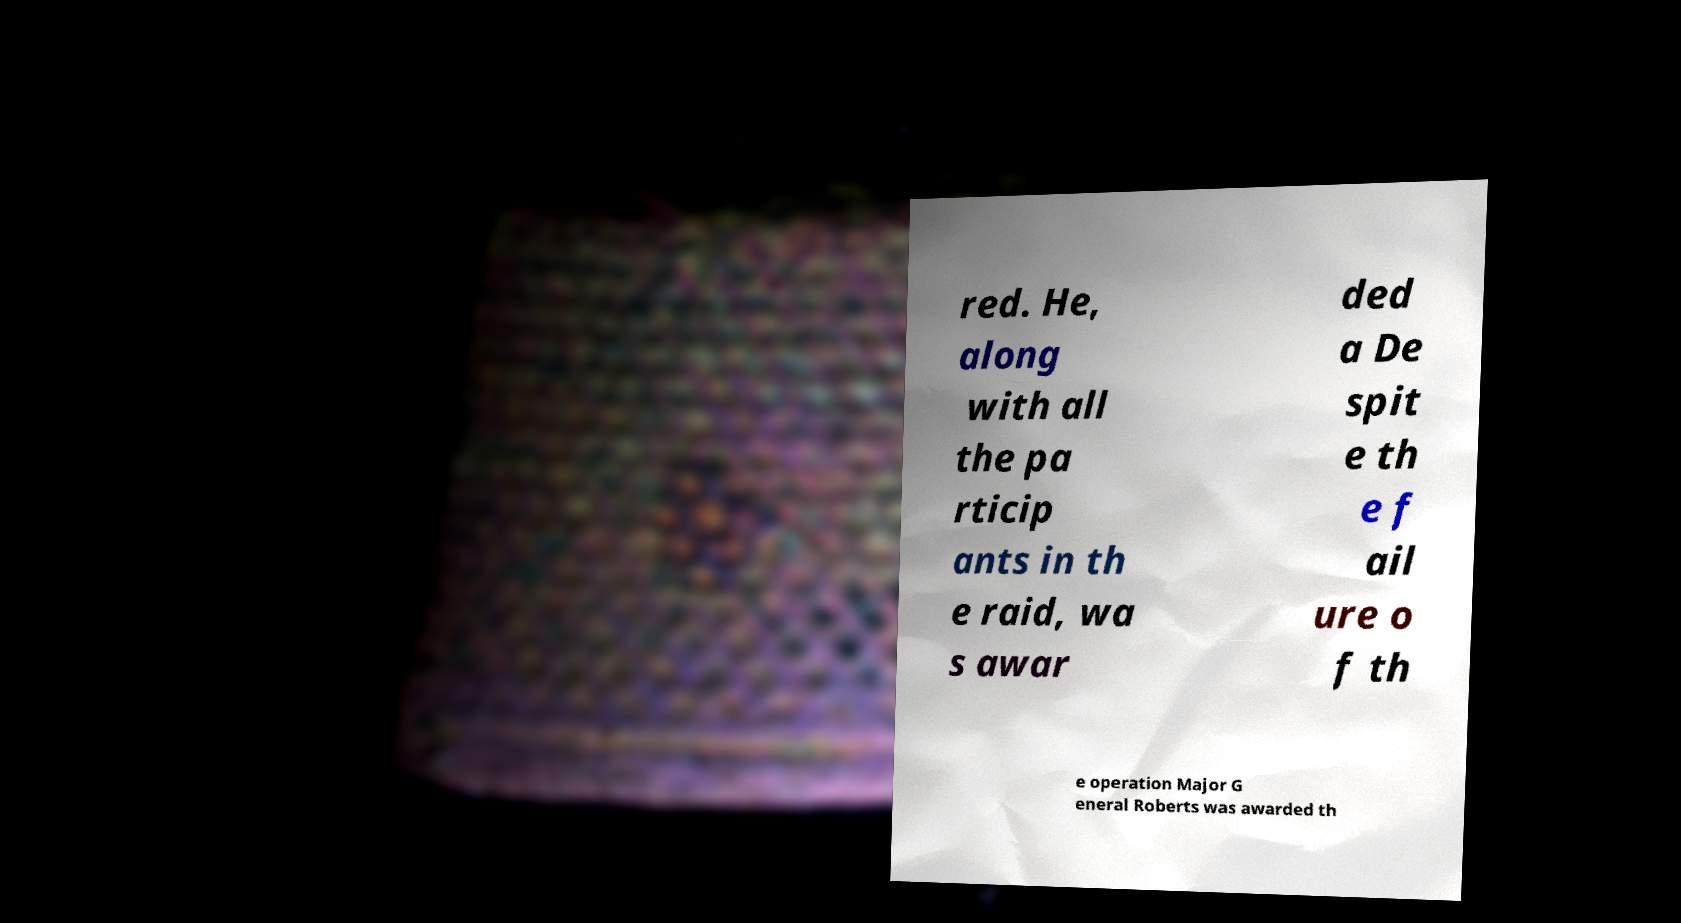Could you assist in decoding the text presented in this image and type it out clearly? red. He, along with all the pa rticip ants in th e raid, wa s awar ded a De spit e th e f ail ure o f th e operation Major G eneral Roberts was awarded th 